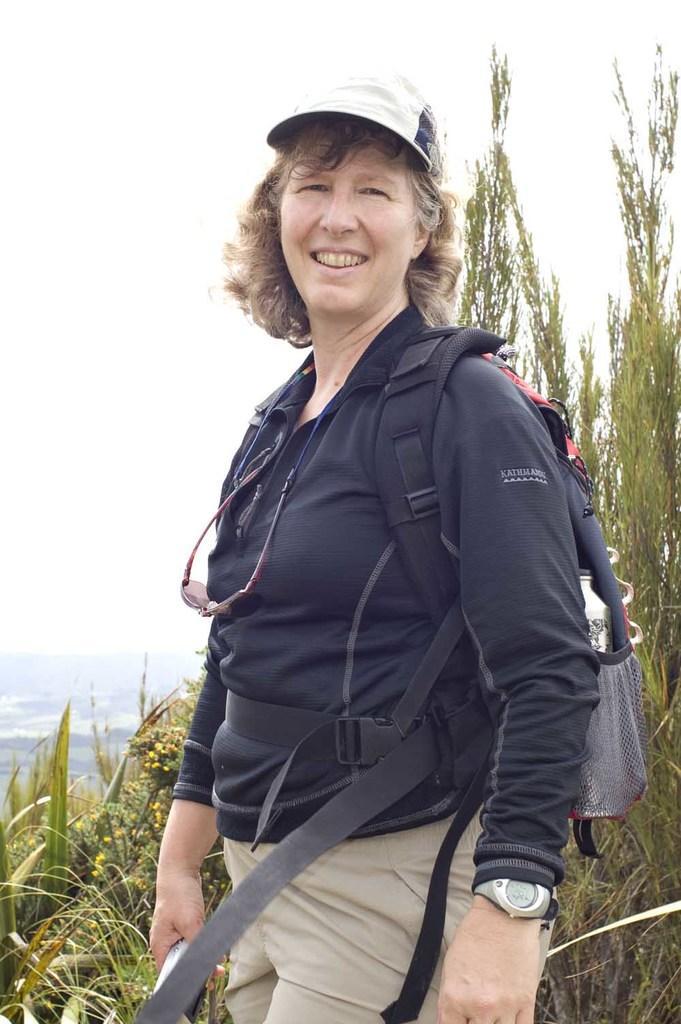In one or two sentences, can you explain what this image depicts? In this picture I can see a woman standing and smiling with a backpack, there are trees, and in the background there is sky. 